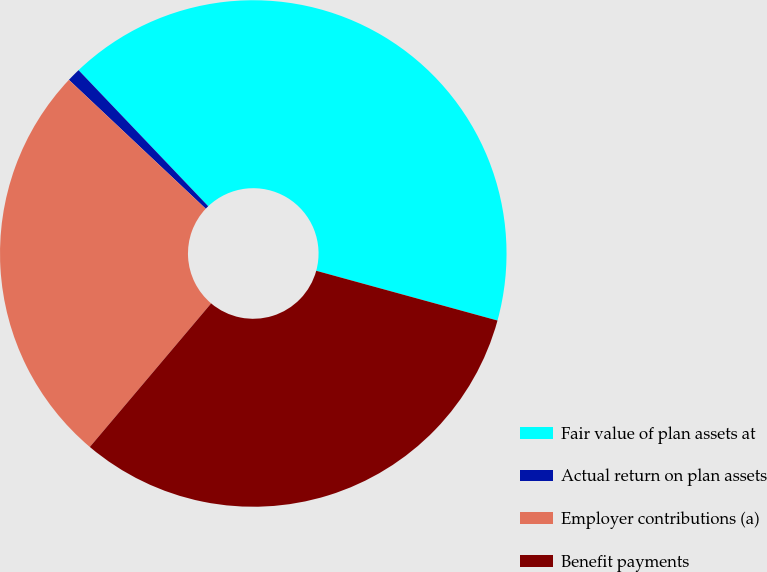<chart> <loc_0><loc_0><loc_500><loc_500><pie_chart><fcel>Fair value of plan assets at<fcel>Actual return on plan assets<fcel>Employer contributions (a)<fcel>Benefit payments<nl><fcel>41.38%<fcel>0.86%<fcel>25.86%<fcel>31.9%<nl></chart> 